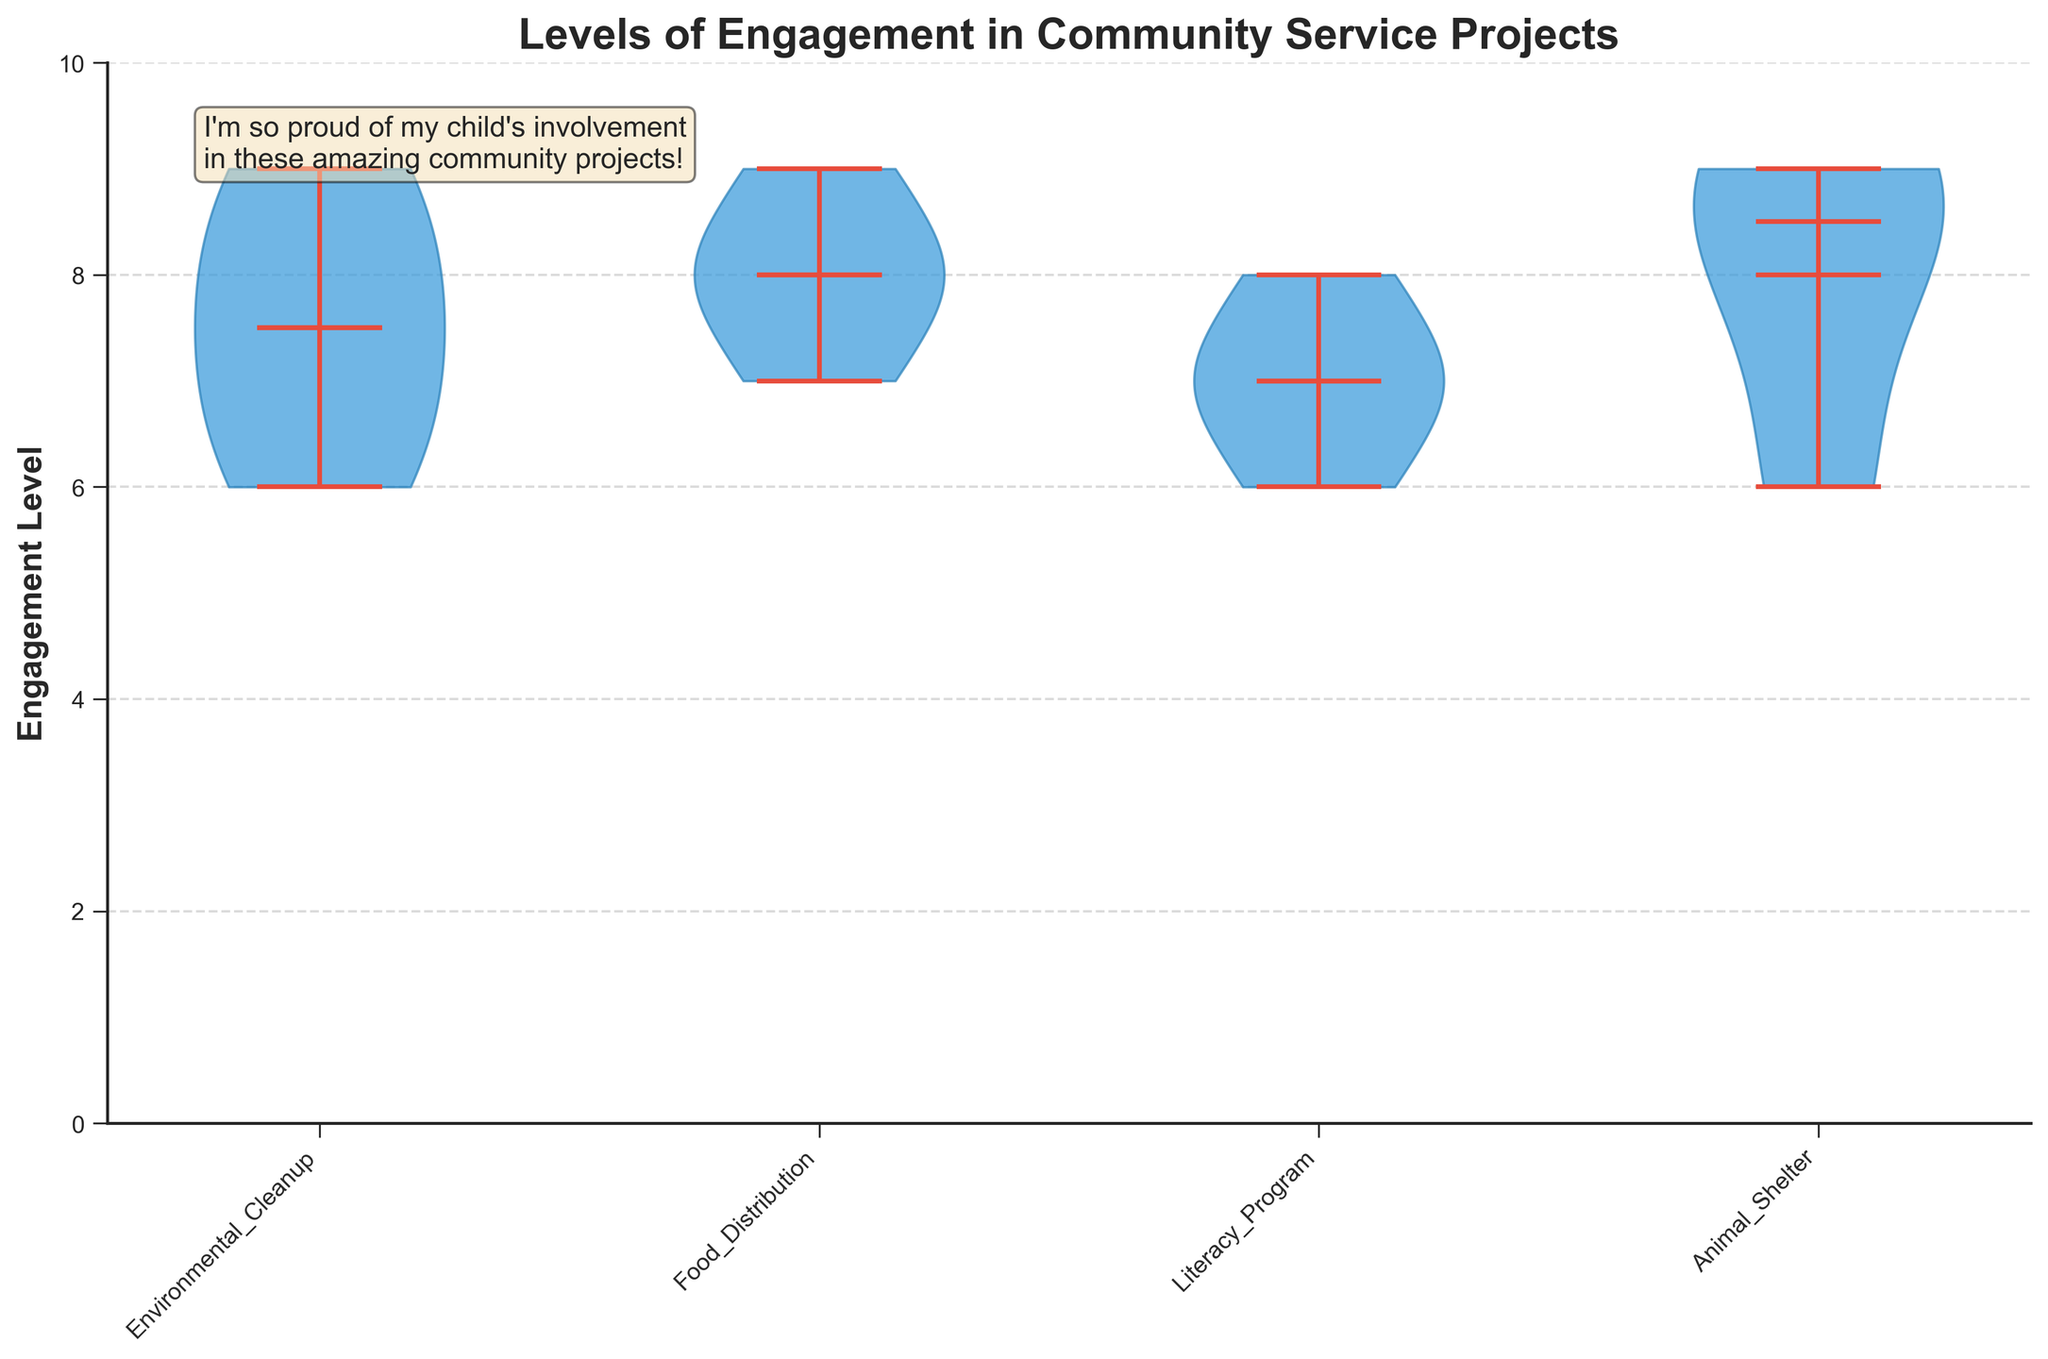What is the title of the violin chart? The title is typically located at the top of the chart. It aims to provide a clear understanding of the content depicted in the chart by summarizing the main theme.
Answer: Levels of Engagement in Community Service Projects What is the maximum engagement level shown on the vertical axis? The vertical axis displays the range of engagement levels from 0 to 10, which is indicated by the axis ticks.
Answer: 10 Which project type shows the highest variation in engagement levels? By visually examining the width and spread of the violin plots for each project type, the Environmental Cleanup project has the widest and most varied distribution.
Answer: Environmental Cleanup Which project type shows the lowest median engagement level? Each violin plot has a line indicating the median level. The Food Distribution project’s median line appears to be at 8, making it the lowest compared to other projects.
Answer: Food Distribution What color are the violin parts in the chart? The violin parts are distinctly colored to make them visually appealing and distinguishable, typically in a blue shade as mentioned (#3498db).
Answer: Blue Which project has the highest mean engagement level? The mean engagement level is depicted by a dot in each violin plot. By examining these dots, the Animal Shelter project has the highest mean engagement level.
Answer: Animal Shelter How many community service projects are being compared in the chart? By counting the distinct labels on the horizontal axis that represent different project types, there are four community service projects.
Answer: Four What type of additional visual enhancements are used to improve the chart's readability and aesthetics? The chart uses features such as custom colors for various parts, a grid pattern on the y-axis, and additional textual elements to convey specific messages.
Answer: Grid, customized colors, text box How does the engagement in the Literacy Program compare to Food Distribution? Comparing the width and central tendencies of the violin plots, the engagement levels are more tightly grouped around the median for the Literacy Program, indicating less variation compared to the Food Distribution project.
Answer: Less variation in Literacy Program 